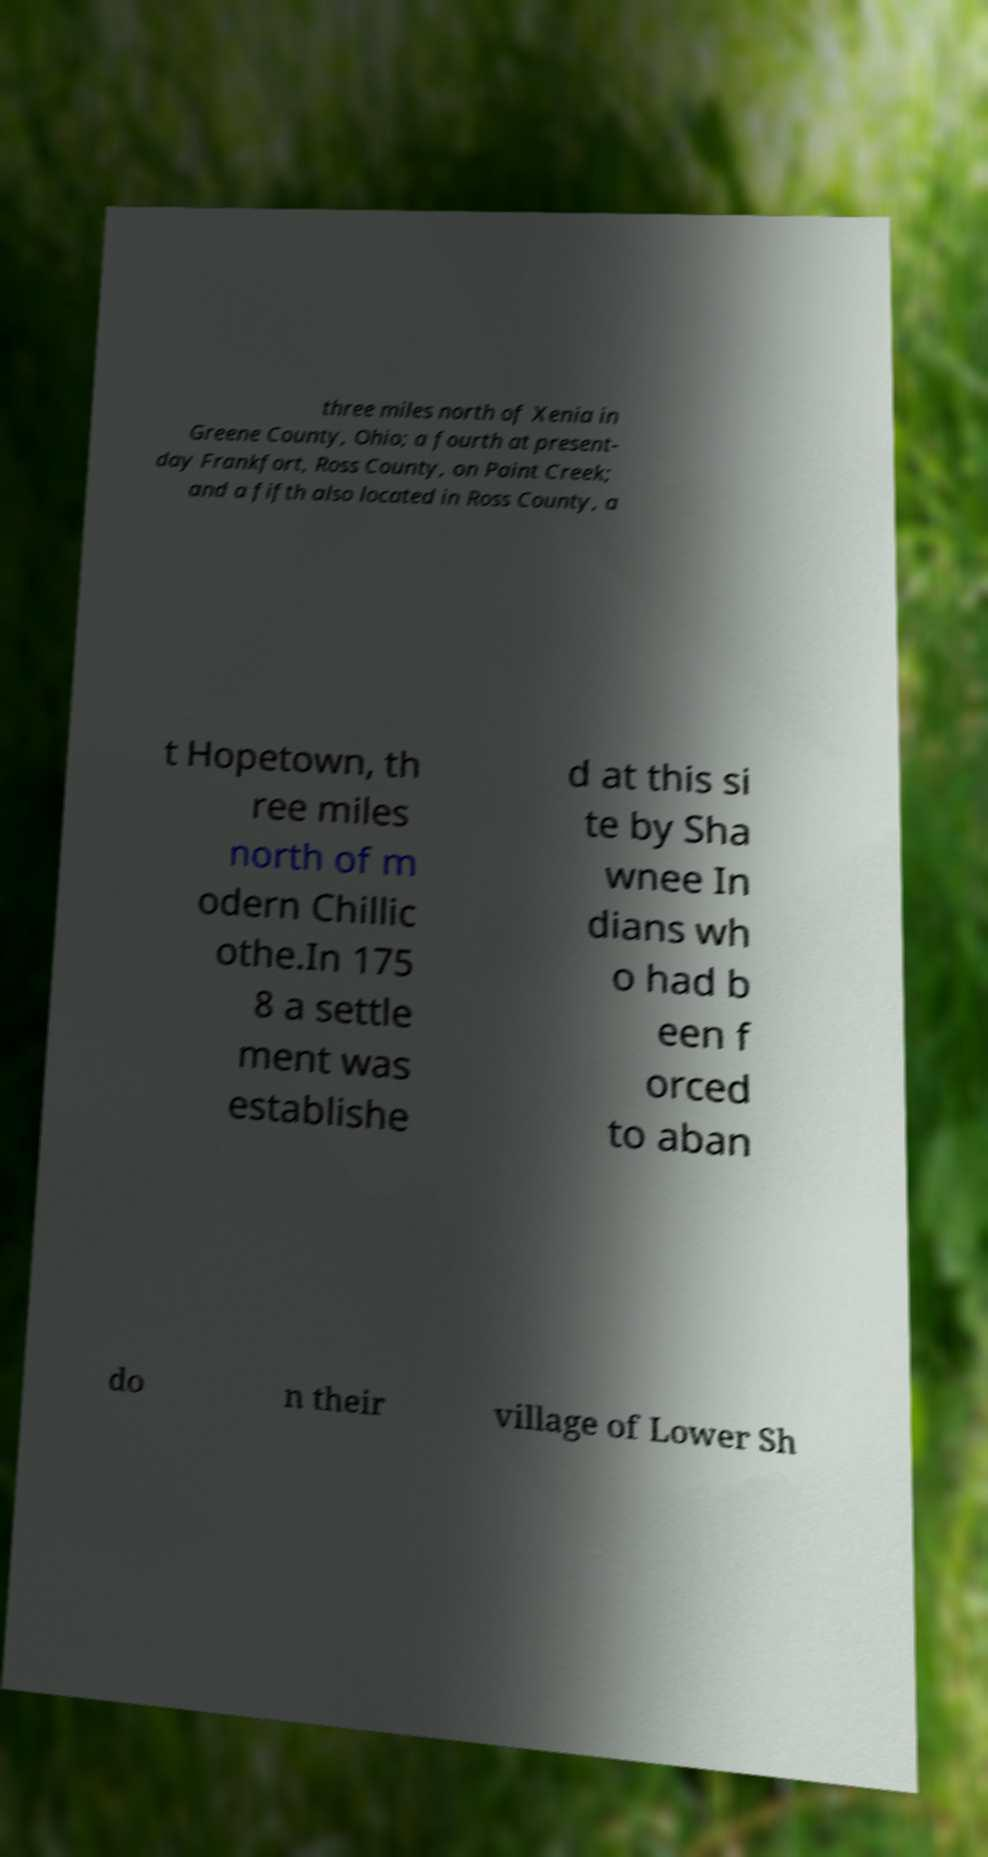Please identify and transcribe the text found in this image. three miles north of Xenia in Greene County, Ohio; a fourth at present- day Frankfort, Ross County, on Paint Creek; and a fifth also located in Ross County, a t Hopetown, th ree miles north of m odern Chillic othe.In 175 8 a settle ment was establishe d at this si te by Sha wnee In dians wh o had b een f orced to aban do n their village of Lower Sh 